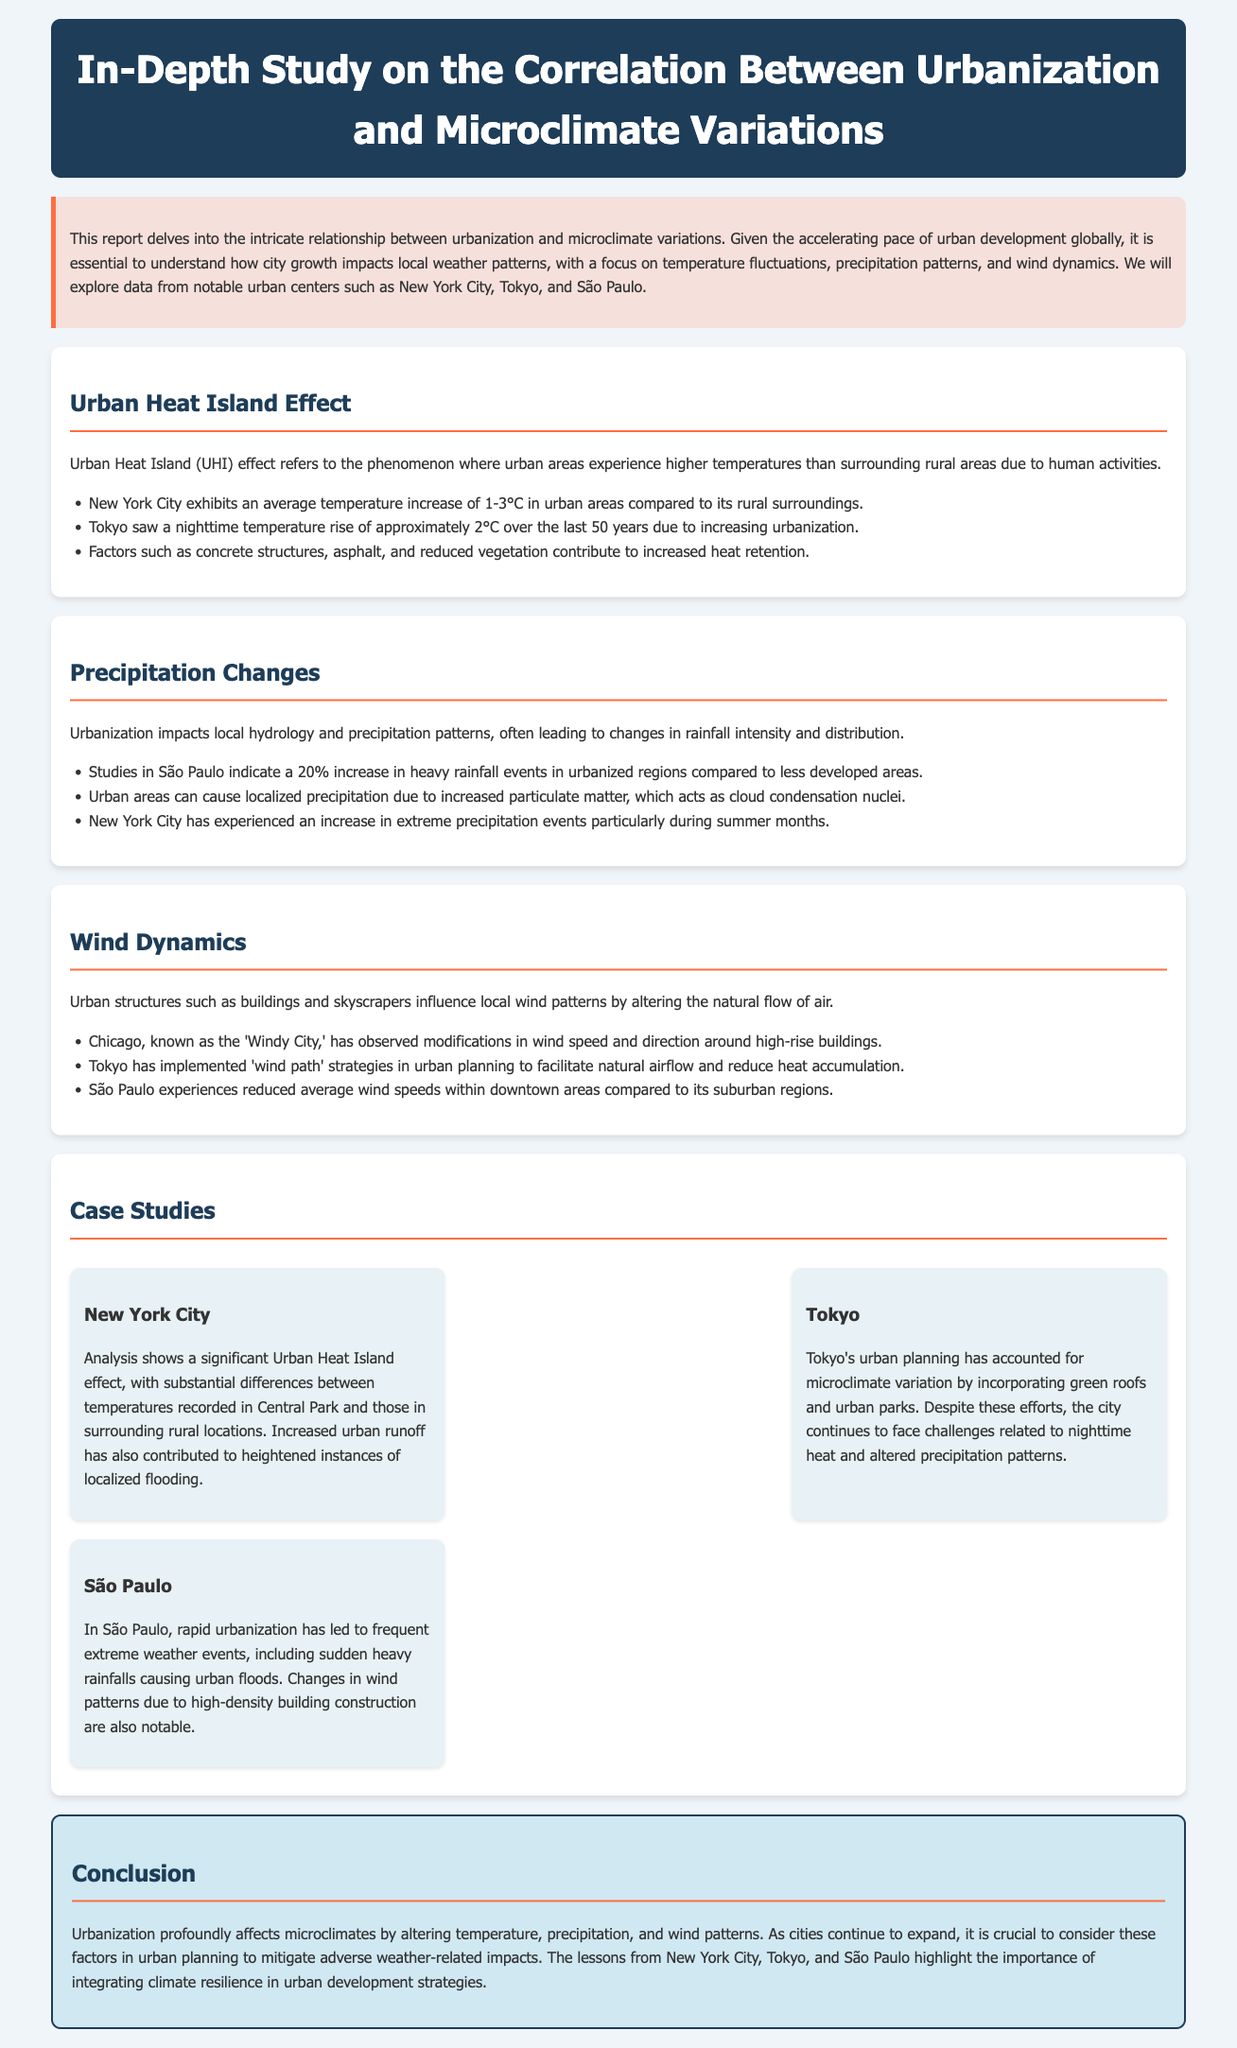what is the title of the report? The title of the report is presented prominently at the top of the document.
Answer: In-Depth Study on the Correlation Between Urbanization and Microclimate Variations what phenomenon does UHI refer to? UHI refers to the specific phenomenon described in the section header.
Answer: Urban Heat Island effect how much has Tokyo's nighttime temperature increased? The specific temperature increase for Tokyo is mentioned in the document.
Answer: approximately 2°C what percentage increase in heavy rainfall events is noted in São Paulo? The document lists the exact percentage increase in heavy rainfall events in the specified region.
Answer: 20% which city incorporates green roofs for urban planning? The document highlights the city that has made efforts in urban planning related to microclimate.
Answer: Tokyo what strategies has Tokyo implemented to facilitate airflow? The document specifies the strategies mentioned in the context of urban planning for Tokyo.
Answer: 'wind path' strategies which three cities are discussed as case studies? The document lists the cities explored in the case study section.
Answer: New York City, Tokyo, São Paulo what is a notable consequence of rapid urbanization in São Paulo? The document highlights a significant consequence of urbanization mentioned in São Paulo's case study.
Answer: extreme weather events 